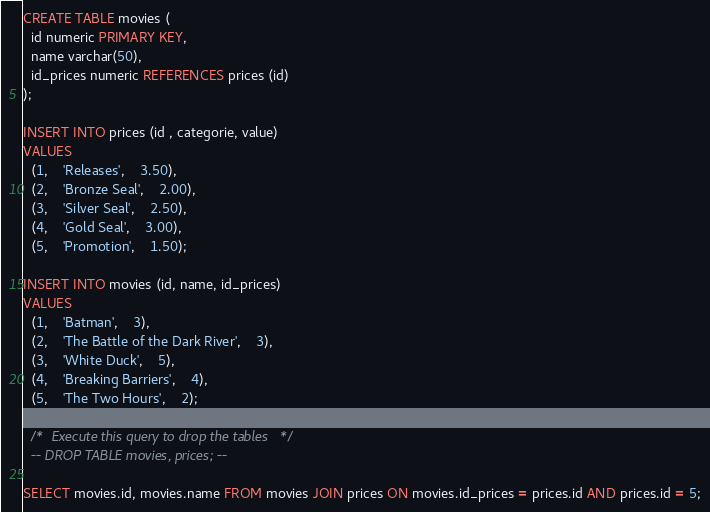Convert code to text. <code><loc_0><loc_0><loc_500><loc_500><_SQL_>
CREATE TABLE movies (
  id numeric PRIMARY KEY,
  name varchar(50),
  id_prices numeric REFERENCES prices (id)
);

INSERT INTO prices (id , categorie, value)
VALUES
  (1,	'Releases',	3.50),
  (2,	'Bronze Seal',	2.00),
  (3,	'Silver Seal',	2.50),
  (4,	'Gold Seal',	3.00),
  (5,	'Promotion',	1.50);
  
INSERT INTO movies (id, name, id_prices)
VALUES
  (1,	'Batman',	3),
  (2,	'The Battle of the Dark River',	3),
  (3,	'White Duck',	5),
  (4,	'Breaking Barriers',	4),
  (5,	'The Two Hours',	2);
  
  /*  Execute this query to drop the tables */
  -- DROP TABLE movies, prices; --

SELECT movies.id, movies.name FROM movies JOIN prices ON movies.id_prices = prices.id AND prices.id = 5;</code> 